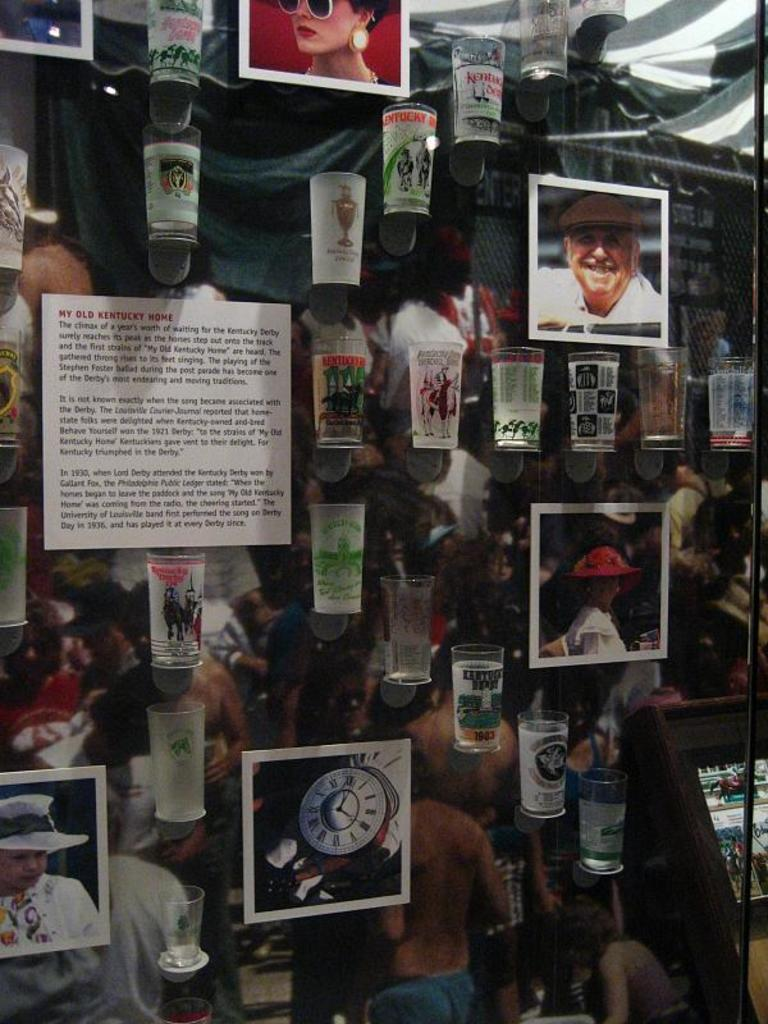What type of objects can be seen in the image? There are photographs, glasses, and a poster in the image. How are the glasses positioned in the image? The glasses are hanged in the image. What is written or depicted on the poster? There is text on the poster. Can you tell me what the cat is doing in the image? There is no cat present in the image. 